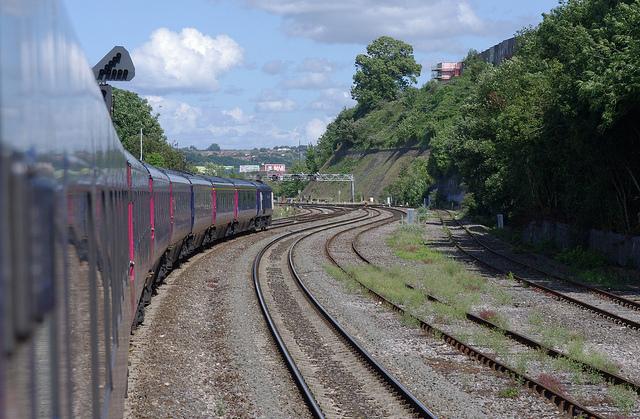Are the tracks straight?
Be succinct. No. How many trains are there?
Give a very brief answer. 1. Is that a long train?
Write a very short answer. Yes. 